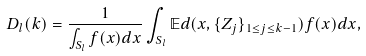<formula> <loc_0><loc_0><loc_500><loc_500>D _ { l } ( k ) = \frac { 1 } { \int _ { S _ { l } } f ( x ) d x } \int _ { S _ { l } } \mathbb { E } d ( x , \{ Z _ { j } \} _ { 1 \leq j \leq k - 1 } ) f ( x ) d x ,</formula> 